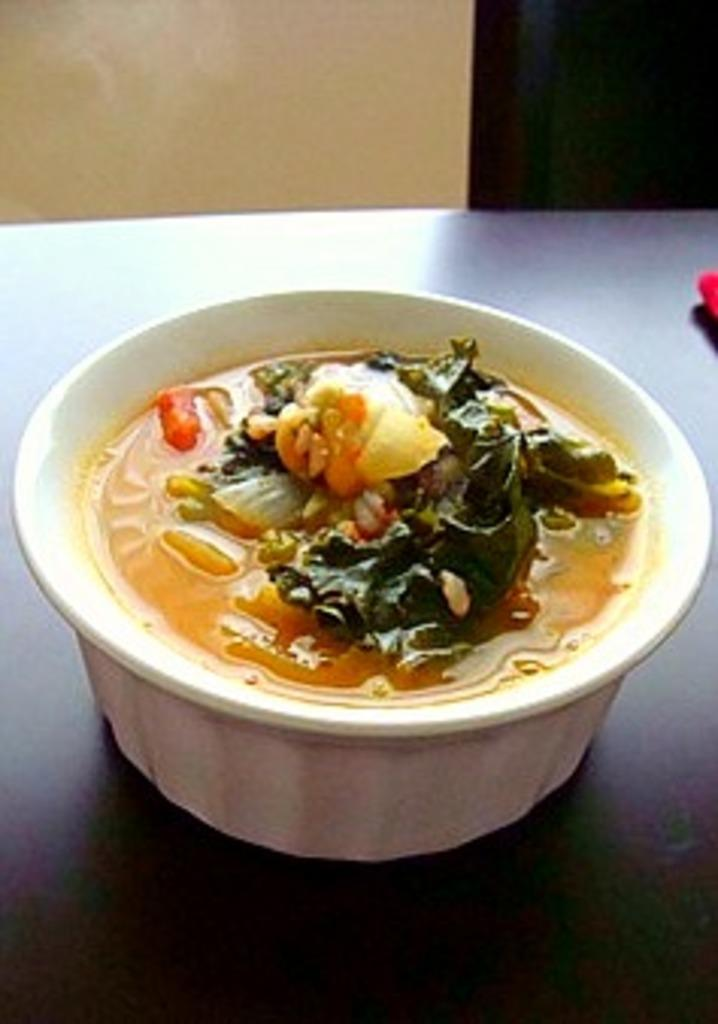What is the main piece of furniture in the image? There is a table in the image. What is on the table? There is a bowl of food on the table. Can you describe the objects on the right side of the image? Unfortunately, the provided facts do not give enough information to describe the objects on the right side of the image. Is there any smoke coming from the bowl of food in the image? No, there is no smoke present in the image. 